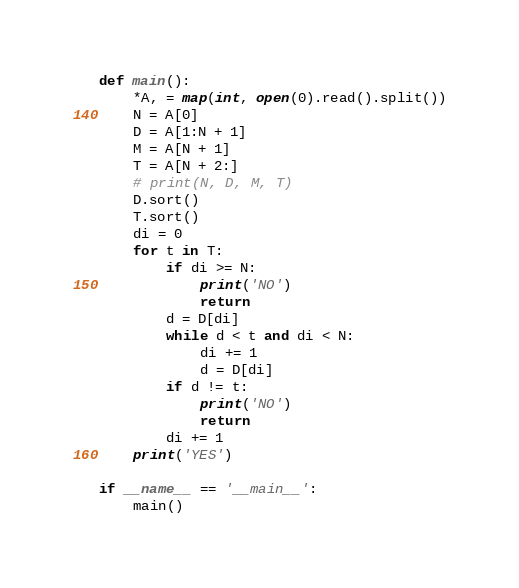Convert code to text. <code><loc_0><loc_0><loc_500><loc_500><_Python_>def main():
    *A, = map(int, open(0).read().split())
    N = A[0]
    D = A[1:N + 1]
    M = A[N + 1]
    T = A[N + 2:]
    # print(N, D, M, T)
    D.sort()
    T.sort()
    di = 0
    for t in T:
        if di >= N:
            print('NO')
            return
        d = D[di]
        while d < t and di < N:
            di += 1
            d = D[di]
        if d != t:
            print('NO')
            return
        di += 1
    print('YES')

if __name__ == '__main__':
    main()
</code> 